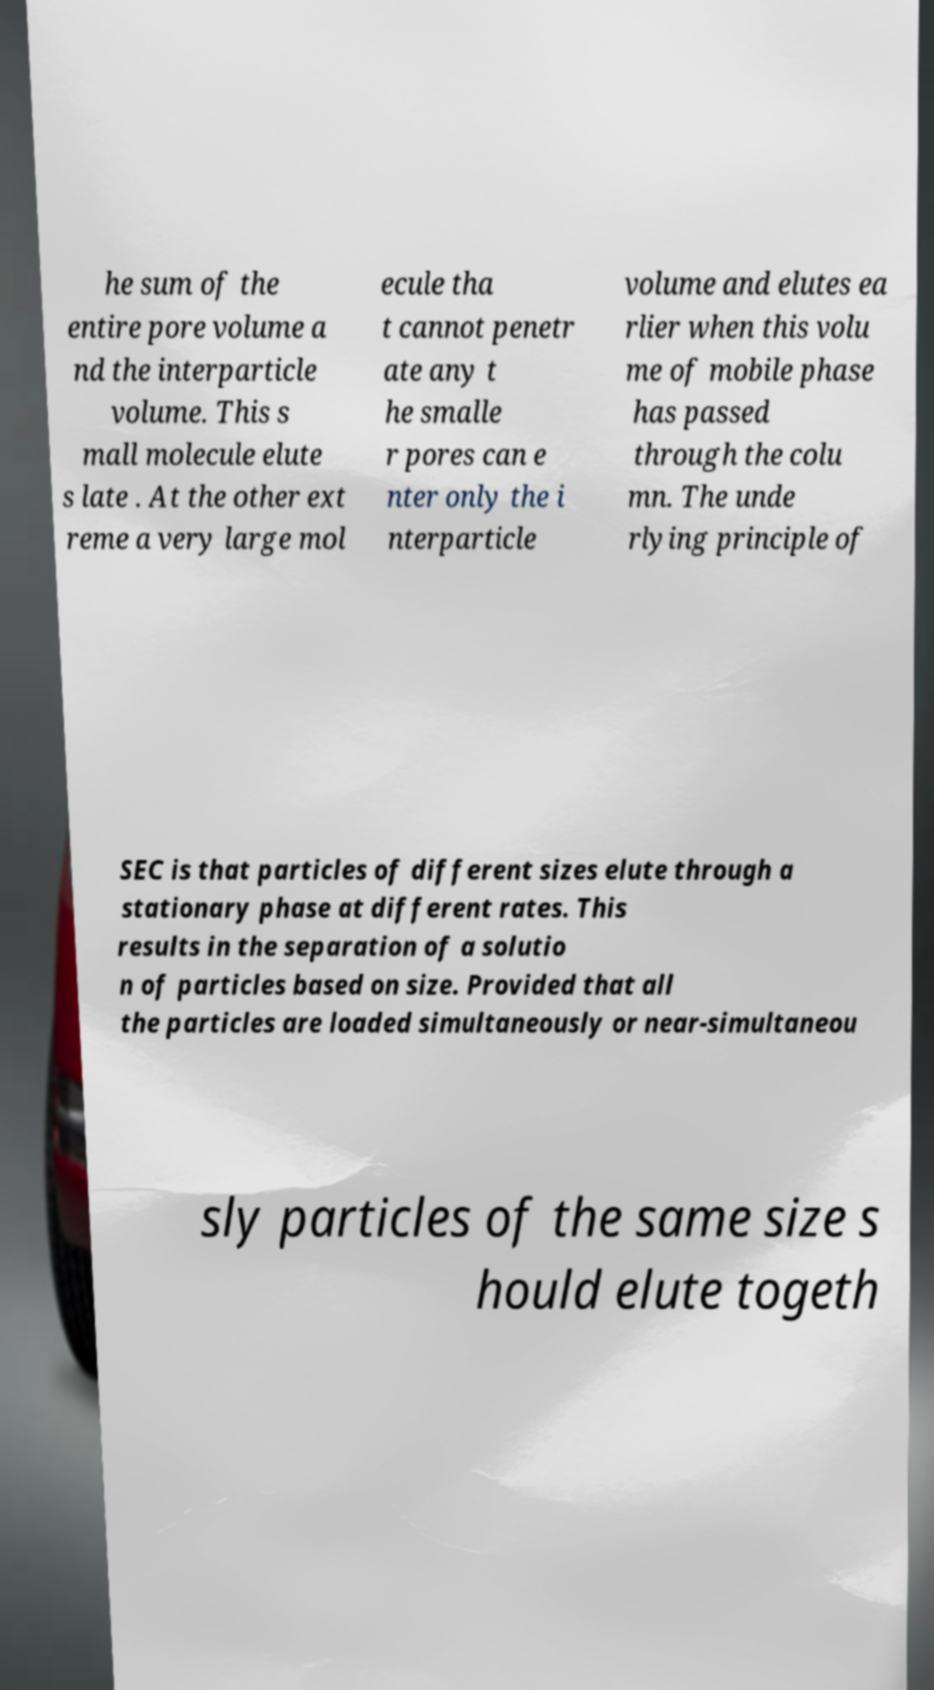Please read and relay the text visible in this image. What does it say? he sum of the entire pore volume a nd the interparticle volume. This s mall molecule elute s late . At the other ext reme a very large mol ecule tha t cannot penetr ate any t he smalle r pores can e nter only the i nterparticle volume and elutes ea rlier when this volu me of mobile phase has passed through the colu mn. The unde rlying principle of SEC is that particles of different sizes elute through a stationary phase at different rates. This results in the separation of a solutio n of particles based on size. Provided that all the particles are loaded simultaneously or near-simultaneou sly particles of the same size s hould elute togeth 